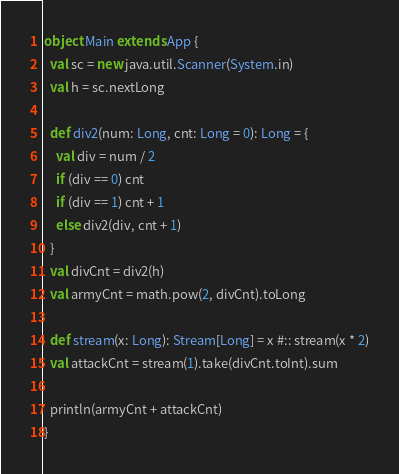<code> <loc_0><loc_0><loc_500><loc_500><_Scala_>object Main extends App {
  val sc = new java.util.Scanner(System.in)
  val h = sc.nextLong
  
  def div2(num: Long, cnt: Long = 0): Long = {
    val div = num / 2
    if (div == 0) cnt
    if (div == 1) cnt + 1
    else div2(div, cnt + 1)
  }
  val divCnt = div2(h)
  val armyCnt = math.pow(2, divCnt).toLong

  def stream(x: Long): Stream[Long] = x #:: stream(x * 2)
  val attackCnt = stream(1).take(divCnt.toInt).sum
  
  println(armyCnt + attackCnt)
}</code> 